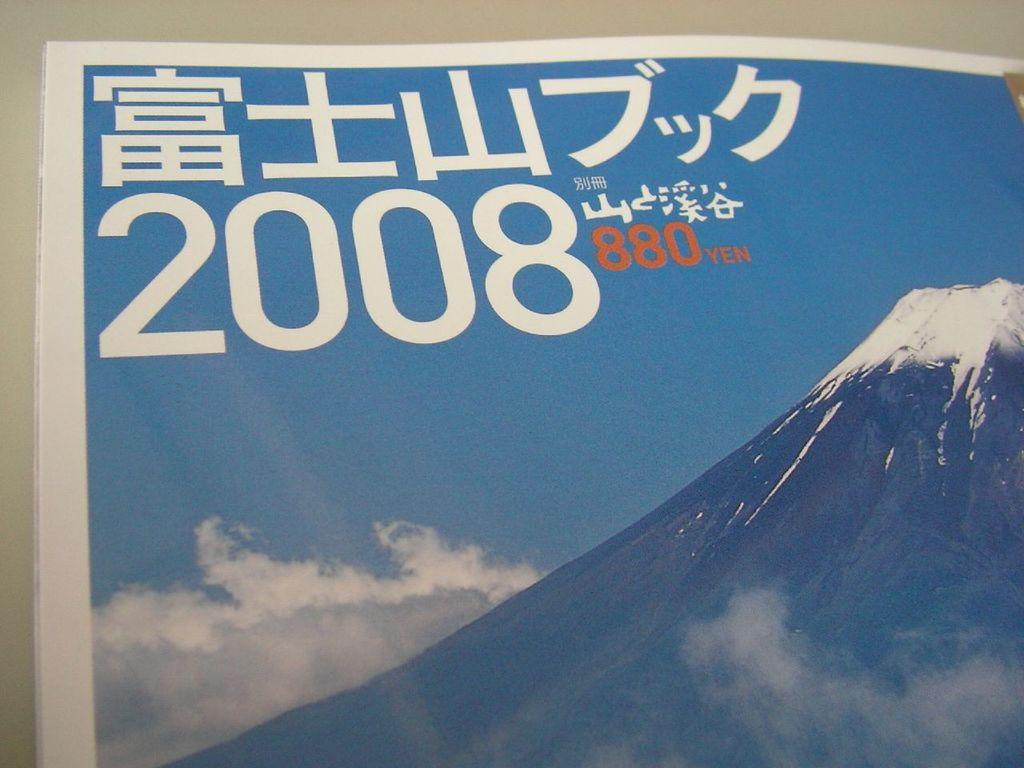<image>
Share a concise interpretation of the image provided. Page showing a mountain and the year 2008. 